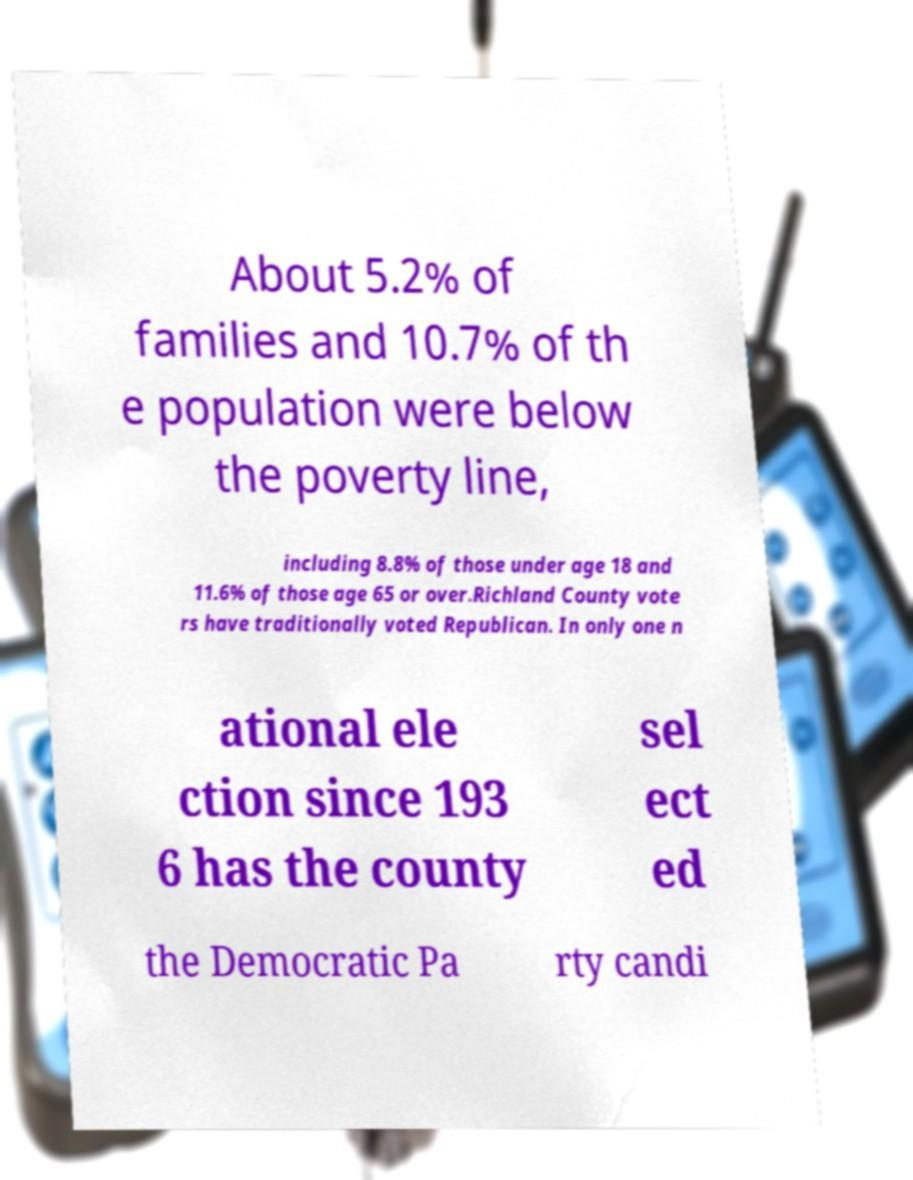I need the written content from this picture converted into text. Can you do that? About 5.2% of families and 10.7% of th e population were below the poverty line, including 8.8% of those under age 18 and 11.6% of those age 65 or over.Richland County vote rs have traditionally voted Republican. In only one n ational ele ction since 193 6 has the county sel ect ed the Democratic Pa rty candi 